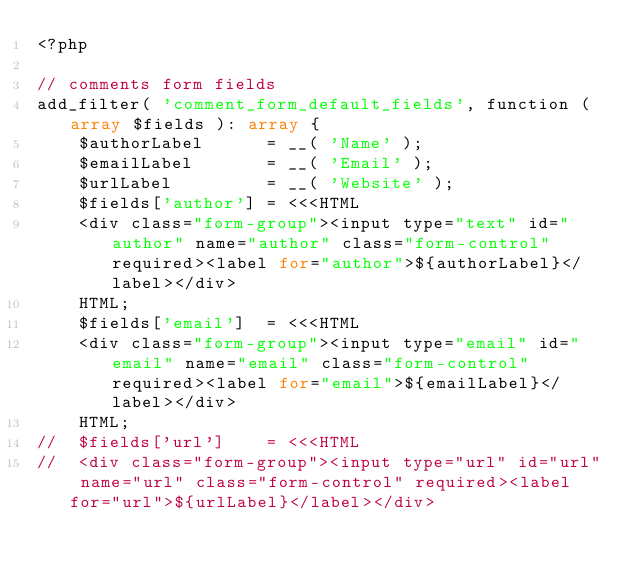Convert code to text. <code><loc_0><loc_0><loc_500><loc_500><_PHP_><?php

// comments form fields
add_filter( 'comment_form_default_fields', function ( array $fields ): array {
	$authorLabel      = __( 'Name' );
	$emailLabel       = __( 'Email' );
	$urlLabel         = __( 'Website' );
	$fields['author'] = <<<HTML
	<div class="form-group"><input type="text" id="author" name="author" class="form-control" required><label for="author">${authorLabel}</label></div>
	HTML;
	$fields['email']  = <<<HTML
	<div class="form-group"><input type="email" id="email" name="email" class="form-control" required><label for="email">${emailLabel}</label></div>
	HTML;
//	$fields['url']    = <<<HTML
//	<div class="form-group"><input type="url" id="url" name="url" class="form-control" required><label for="url">${urlLabel}</label></div></code> 